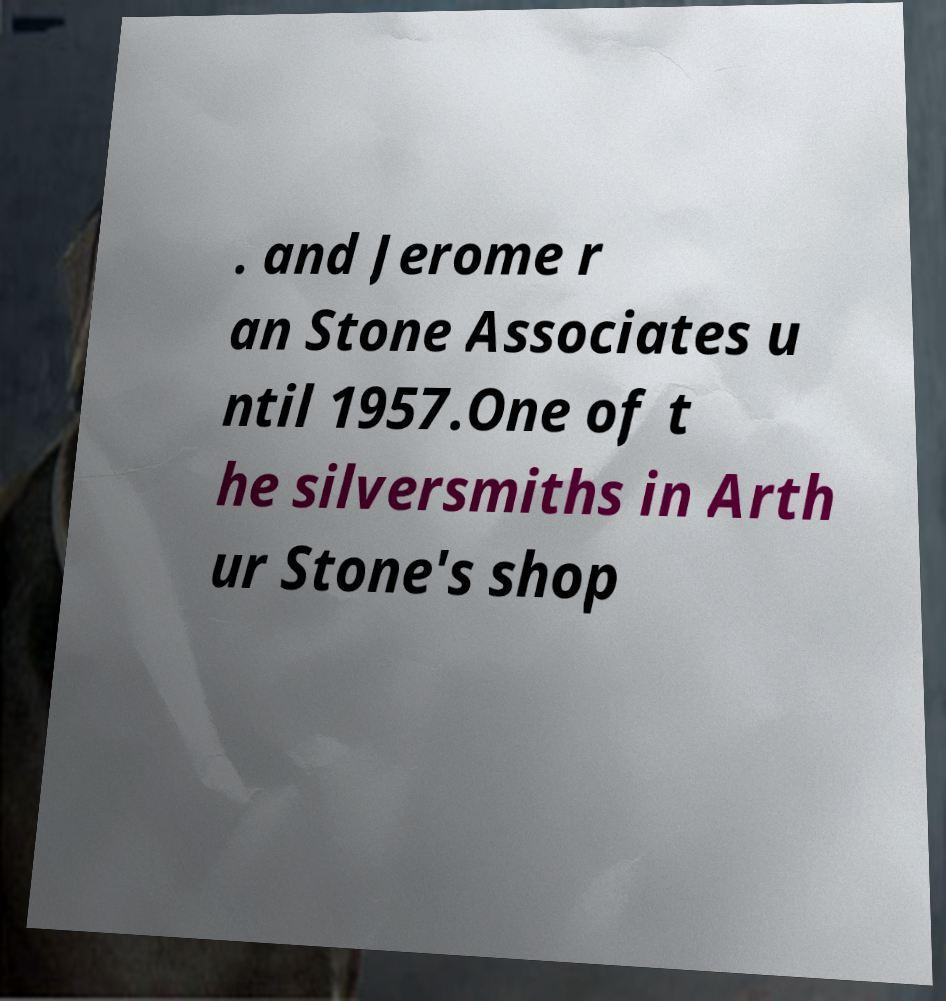There's text embedded in this image that I need extracted. Can you transcribe it verbatim? . and Jerome r an Stone Associates u ntil 1957.One of t he silversmiths in Arth ur Stone's shop 